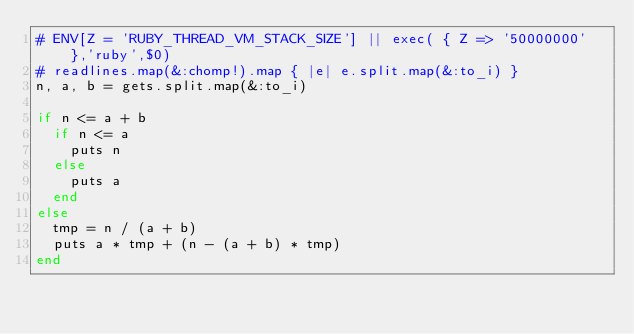Convert code to text. <code><loc_0><loc_0><loc_500><loc_500><_Ruby_># ENV[Z = 'RUBY_THREAD_VM_STACK_SIZE'] || exec( { Z => '50000000' },'ruby',$0)
# readlines.map(&:chomp!).map { |e| e.split.map(&:to_i) }
n, a, b = gets.split.map(&:to_i)

if n <= a + b
  if n <= a
    puts n
  else
    puts a
  end
else
  tmp = n / (a + b)
  puts a * tmp + (n - (a + b) * tmp)
end
</code> 